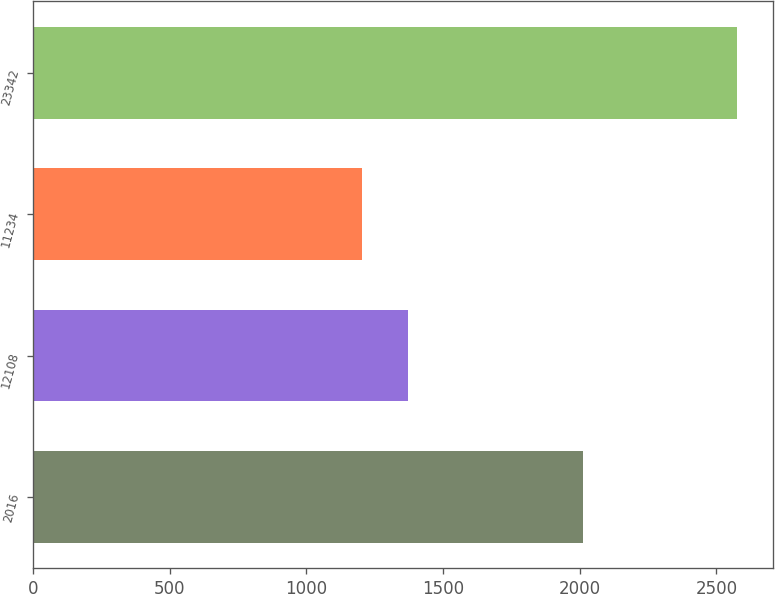Convert chart to OTSL. <chart><loc_0><loc_0><loc_500><loc_500><bar_chart><fcel>2016<fcel>12108<fcel>11234<fcel>23342<nl><fcel>2014<fcel>1372.2<fcel>1204.9<fcel>2577.1<nl></chart> 